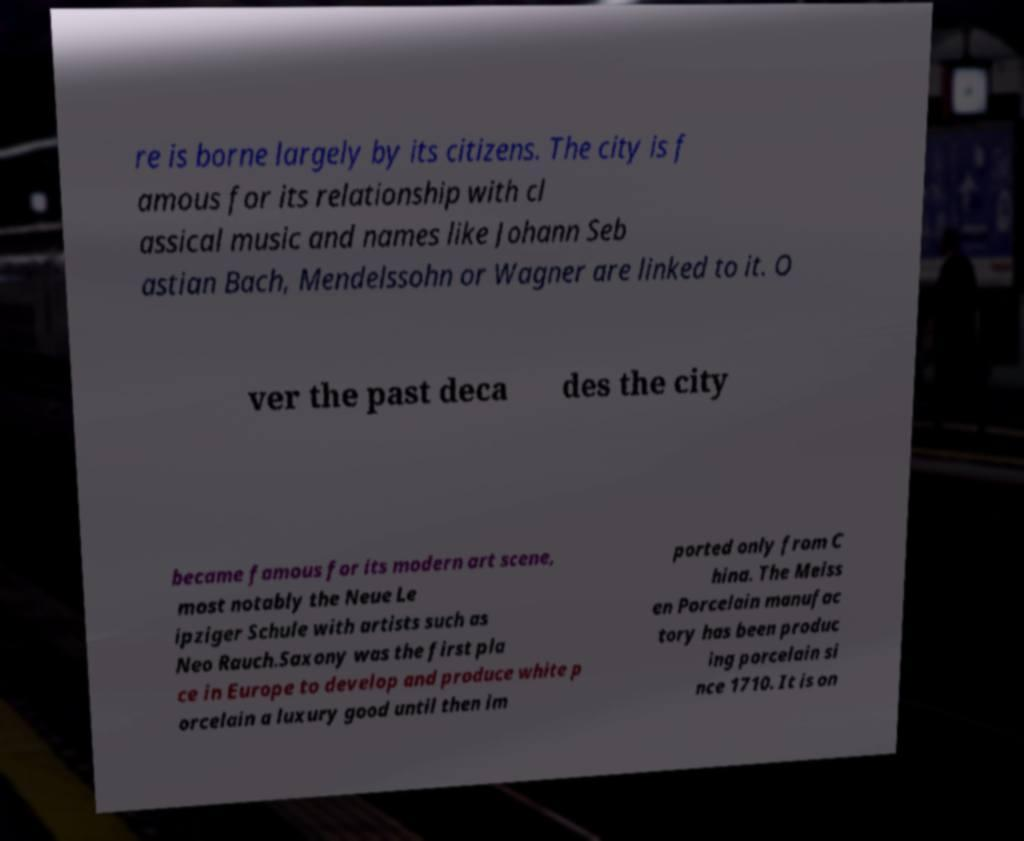There's text embedded in this image that I need extracted. Can you transcribe it verbatim? re is borne largely by its citizens. The city is f amous for its relationship with cl assical music and names like Johann Seb astian Bach, Mendelssohn or Wagner are linked to it. O ver the past deca des the city became famous for its modern art scene, most notably the Neue Le ipziger Schule with artists such as Neo Rauch.Saxony was the first pla ce in Europe to develop and produce white p orcelain a luxury good until then im ported only from C hina. The Meiss en Porcelain manufac tory has been produc ing porcelain si nce 1710. It is on 